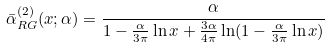<formula> <loc_0><loc_0><loc_500><loc_500>\bar { \alpha } _ { R G } ^ { ( 2 ) } ( x ; \alpha ) = \frac { \alpha } { 1 - \frac { \alpha } { 3 \pi } \ln x + \frac { 3 \alpha } { 4 \pi } \ln ( 1 - \frac { \alpha } { 3 \pi } \ln x ) }</formula> 